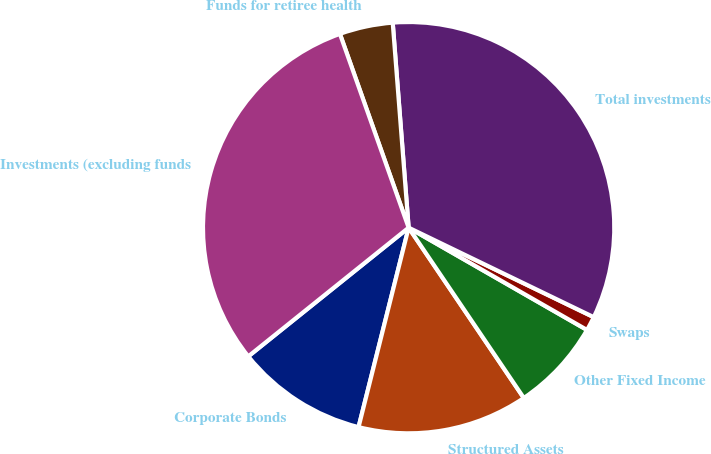Convert chart. <chart><loc_0><loc_0><loc_500><loc_500><pie_chart><fcel>Corporate Bonds<fcel>Structured Assets<fcel>Other Fixed Income<fcel>Swaps<fcel>Total investments<fcel>Funds for retiree health<fcel>Investments (excluding funds<nl><fcel>10.32%<fcel>13.38%<fcel>7.25%<fcel>1.12%<fcel>33.4%<fcel>4.19%<fcel>30.34%<nl></chart> 